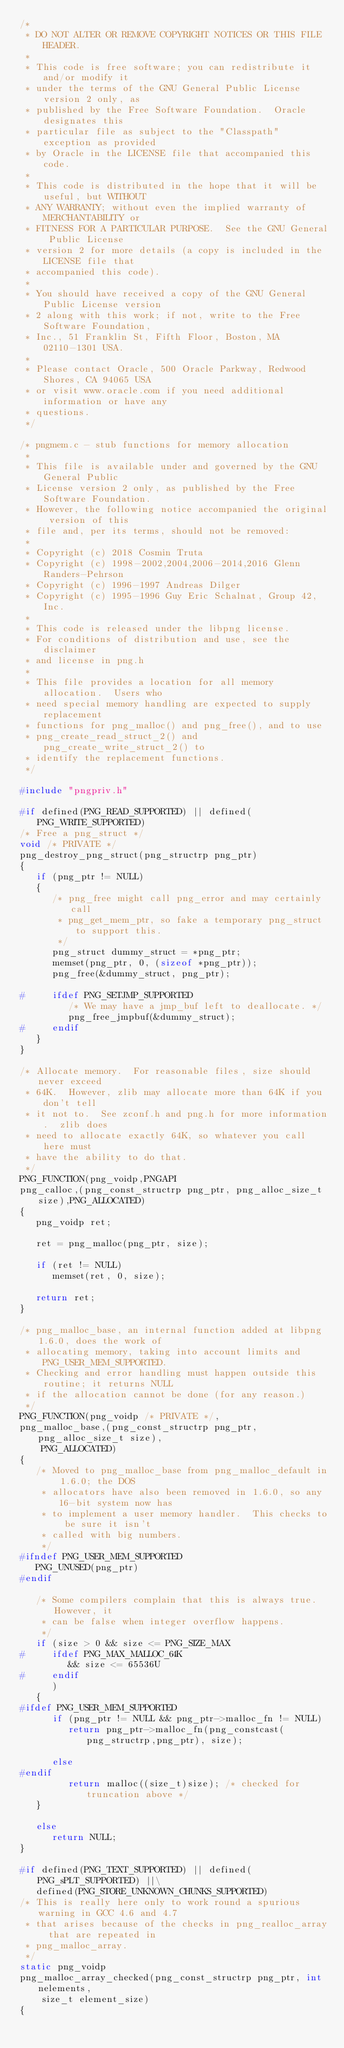<code> <loc_0><loc_0><loc_500><loc_500><_C_>/*
 * DO NOT ALTER OR REMOVE COPYRIGHT NOTICES OR THIS FILE HEADER.
 *
 * This code is free software; you can redistribute it and/or modify it
 * under the terms of the GNU General Public License version 2 only, as
 * published by the Free Software Foundation.  Oracle designates this
 * particular file as subject to the "Classpath" exception as provided
 * by Oracle in the LICENSE file that accompanied this code.
 *
 * This code is distributed in the hope that it will be useful, but WITHOUT
 * ANY WARRANTY; without even the implied warranty of MERCHANTABILITY or
 * FITNESS FOR A PARTICULAR PURPOSE.  See the GNU General Public License
 * version 2 for more details (a copy is included in the LICENSE file that
 * accompanied this code).
 *
 * You should have received a copy of the GNU General Public License version
 * 2 along with this work; if not, write to the Free Software Foundation,
 * Inc., 51 Franklin St, Fifth Floor, Boston, MA 02110-1301 USA.
 *
 * Please contact Oracle, 500 Oracle Parkway, Redwood Shores, CA 94065 USA
 * or visit www.oracle.com if you need additional information or have any
 * questions.
 */

/* pngmem.c - stub functions for memory allocation
 *
 * This file is available under and governed by the GNU General Public
 * License version 2 only, as published by the Free Software Foundation.
 * However, the following notice accompanied the original version of this
 * file and, per its terms, should not be removed:
 *
 * Copyright (c) 2018 Cosmin Truta
 * Copyright (c) 1998-2002,2004,2006-2014,2016 Glenn Randers-Pehrson
 * Copyright (c) 1996-1997 Andreas Dilger
 * Copyright (c) 1995-1996 Guy Eric Schalnat, Group 42, Inc.
 *
 * This code is released under the libpng license.
 * For conditions of distribution and use, see the disclaimer
 * and license in png.h
 *
 * This file provides a location for all memory allocation.  Users who
 * need special memory handling are expected to supply replacement
 * functions for png_malloc() and png_free(), and to use
 * png_create_read_struct_2() and png_create_write_struct_2() to
 * identify the replacement functions.
 */

#include "pngpriv.h"

#if defined(PNG_READ_SUPPORTED) || defined(PNG_WRITE_SUPPORTED)
/* Free a png_struct */
void /* PRIVATE */
png_destroy_png_struct(png_structrp png_ptr)
{
   if (png_ptr != NULL)
   {
      /* png_free might call png_error and may certainly call
       * png_get_mem_ptr, so fake a temporary png_struct to support this.
       */
      png_struct dummy_struct = *png_ptr;
      memset(png_ptr, 0, (sizeof *png_ptr));
      png_free(&dummy_struct, png_ptr);

#     ifdef PNG_SETJMP_SUPPORTED
         /* We may have a jmp_buf left to deallocate. */
         png_free_jmpbuf(&dummy_struct);
#     endif
   }
}

/* Allocate memory.  For reasonable files, size should never exceed
 * 64K.  However, zlib may allocate more than 64K if you don't tell
 * it not to.  See zconf.h and png.h for more information.  zlib does
 * need to allocate exactly 64K, so whatever you call here must
 * have the ability to do that.
 */
PNG_FUNCTION(png_voidp,PNGAPI
png_calloc,(png_const_structrp png_ptr, png_alloc_size_t size),PNG_ALLOCATED)
{
   png_voidp ret;

   ret = png_malloc(png_ptr, size);

   if (ret != NULL)
      memset(ret, 0, size);

   return ret;
}

/* png_malloc_base, an internal function added at libpng 1.6.0, does the work of
 * allocating memory, taking into account limits and PNG_USER_MEM_SUPPORTED.
 * Checking and error handling must happen outside this routine; it returns NULL
 * if the allocation cannot be done (for any reason.)
 */
PNG_FUNCTION(png_voidp /* PRIVATE */,
png_malloc_base,(png_const_structrp png_ptr, png_alloc_size_t size),
    PNG_ALLOCATED)
{
   /* Moved to png_malloc_base from png_malloc_default in 1.6.0; the DOS
    * allocators have also been removed in 1.6.0, so any 16-bit system now has
    * to implement a user memory handler.  This checks to be sure it isn't
    * called with big numbers.
    */
#ifndef PNG_USER_MEM_SUPPORTED
   PNG_UNUSED(png_ptr)
#endif

   /* Some compilers complain that this is always true.  However, it
    * can be false when integer overflow happens.
    */
   if (size > 0 && size <= PNG_SIZE_MAX
#     ifdef PNG_MAX_MALLOC_64K
         && size <= 65536U
#     endif
      )
   {
#ifdef PNG_USER_MEM_SUPPORTED
      if (png_ptr != NULL && png_ptr->malloc_fn != NULL)
         return png_ptr->malloc_fn(png_constcast(png_structrp,png_ptr), size);

      else
#endif
         return malloc((size_t)size); /* checked for truncation above */
   }

   else
      return NULL;
}

#if defined(PNG_TEXT_SUPPORTED) || defined(PNG_sPLT_SUPPORTED) ||\
   defined(PNG_STORE_UNKNOWN_CHUNKS_SUPPORTED)
/* This is really here only to work round a spurious warning in GCC 4.6 and 4.7
 * that arises because of the checks in png_realloc_array that are repeated in
 * png_malloc_array.
 */
static png_voidp
png_malloc_array_checked(png_const_structrp png_ptr, int nelements,
    size_t element_size)
{</code> 